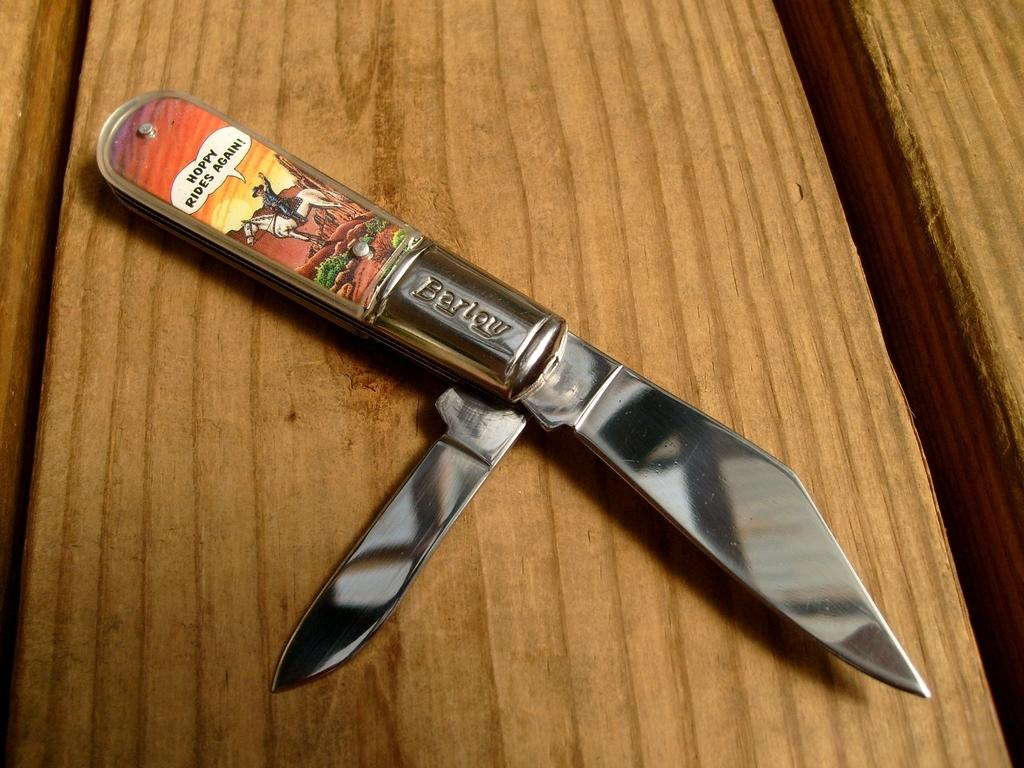What object is present in the image that is typically used for cutting? There is a knife in the image. On what surface is the knife placed? The knife is on a wooden table. What type of trip is the owner of the knife planning to take in the image? There is no information about a trip or the owner of the knife in the image. What expression can be seen on the face of the knife in the image? Knives do not have faces or expressions, so this question cannot be answered. 